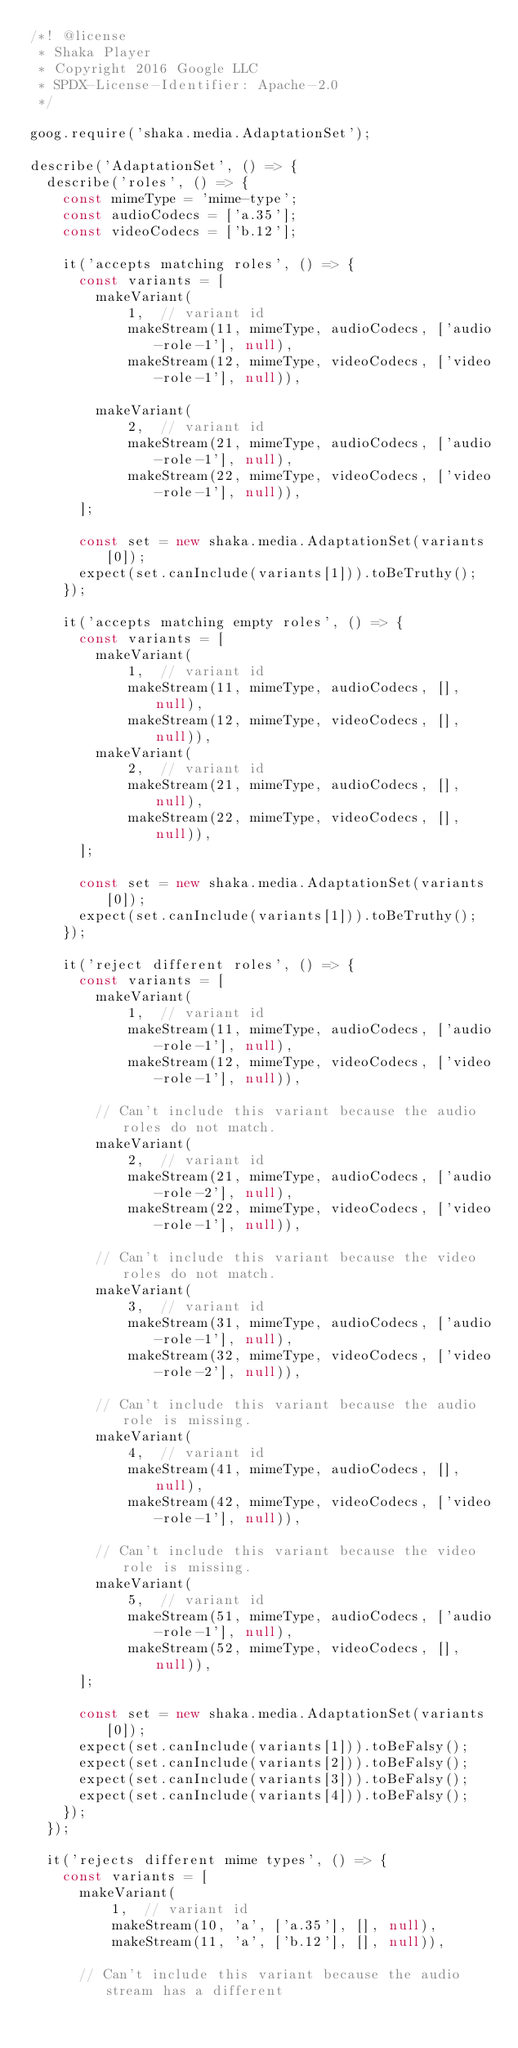Convert code to text. <code><loc_0><loc_0><loc_500><loc_500><_JavaScript_>/*! @license
 * Shaka Player
 * Copyright 2016 Google LLC
 * SPDX-License-Identifier: Apache-2.0
 */

goog.require('shaka.media.AdaptationSet');

describe('AdaptationSet', () => {
  describe('roles', () => {
    const mimeType = 'mime-type';
    const audioCodecs = ['a.35'];
    const videoCodecs = ['b.12'];

    it('accepts matching roles', () => {
      const variants = [
        makeVariant(
            1,  // variant id
            makeStream(11, mimeType, audioCodecs, ['audio-role-1'], null),
            makeStream(12, mimeType, videoCodecs, ['video-role-1'], null)),

        makeVariant(
            2,  // variant id
            makeStream(21, mimeType, audioCodecs, ['audio-role-1'], null),
            makeStream(22, mimeType, videoCodecs, ['video-role-1'], null)),
      ];

      const set = new shaka.media.AdaptationSet(variants[0]);
      expect(set.canInclude(variants[1])).toBeTruthy();
    });

    it('accepts matching empty roles', () => {
      const variants = [
        makeVariant(
            1,  // variant id
            makeStream(11, mimeType, audioCodecs, [], null),
            makeStream(12, mimeType, videoCodecs, [], null)),
        makeVariant(
            2,  // variant id
            makeStream(21, mimeType, audioCodecs, [], null),
            makeStream(22, mimeType, videoCodecs, [], null)),
      ];

      const set = new shaka.media.AdaptationSet(variants[0]);
      expect(set.canInclude(variants[1])).toBeTruthy();
    });

    it('reject different roles', () => {
      const variants = [
        makeVariant(
            1,  // variant id
            makeStream(11, mimeType, audioCodecs, ['audio-role-1'], null),
            makeStream(12, mimeType, videoCodecs, ['video-role-1'], null)),

        // Can't include this variant because the audio roles do not match.
        makeVariant(
            2,  // variant id
            makeStream(21, mimeType, audioCodecs, ['audio-role-2'], null),
            makeStream(22, mimeType, videoCodecs, ['video-role-1'], null)),

        // Can't include this variant because the video roles do not match.
        makeVariant(
            3,  // variant id
            makeStream(31, mimeType, audioCodecs, ['audio-role-1'], null),
            makeStream(32, mimeType, videoCodecs, ['video-role-2'], null)),

        // Can't include this variant because the audio role is missing.
        makeVariant(
            4,  // variant id
            makeStream(41, mimeType, audioCodecs, [], null),
            makeStream(42, mimeType, videoCodecs, ['video-role-1'], null)),

        // Can't include this variant because the video role is missing.
        makeVariant(
            5,  // variant id
            makeStream(51, mimeType, audioCodecs, ['audio-role-1'], null),
            makeStream(52, mimeType, videoCodecs, [], null)),
      ];

      const set = new shaka.media.AdaptationSet(variants[0]);
      expect(set.canInclude(variants[1])).toBeFalsy();
      expect(set.canInclude(variants[2])).toBeFalsy();
      expect(set.canInclude(variants[3])).toBeFalsy();
      expect(set.canInclude(variants[4])).toBeFalsy();
    });
  });

  it('rejects different mime types', () => {
    const variants = [
      makeVariant(
          1,  // variant id
          makeStream(10, 'a', ['a.35'], [], null),
          makeStream(11, 'a', ['b.12'], [], null)),

      // Can't include this variant because the audio stream has a different</code> 